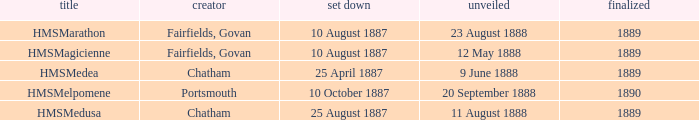What boat was laid down on 25 april 1887? HMSMedea. 